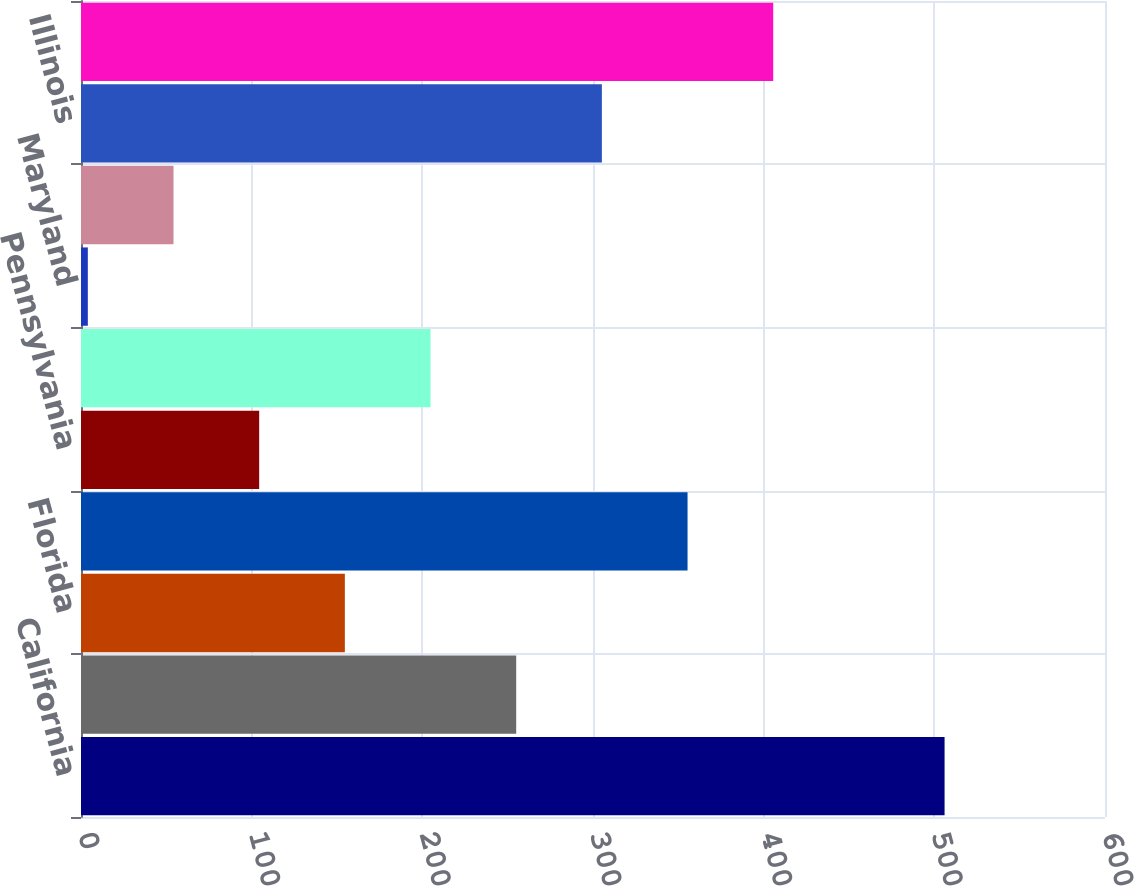Convert chart. <chart><loc_0><loc_0><loc_500><loc_500><bar_chart><fcel>California<fcel>NewYork<fcel>Florida<fcel>Texas<fcel>Pennsylvania<fcel>Ohio<fcel>Maryland<fcel>Arizona<fcel>Illinois<fcel>Other states<nl><fcel>506<fcel>255<fcel>154.6<fcel>355.4<fcel>104.4<fcel>204.8<fcel>4<fcel>54.2<fcel>305.2<fcel>405.6<nl></chart> 